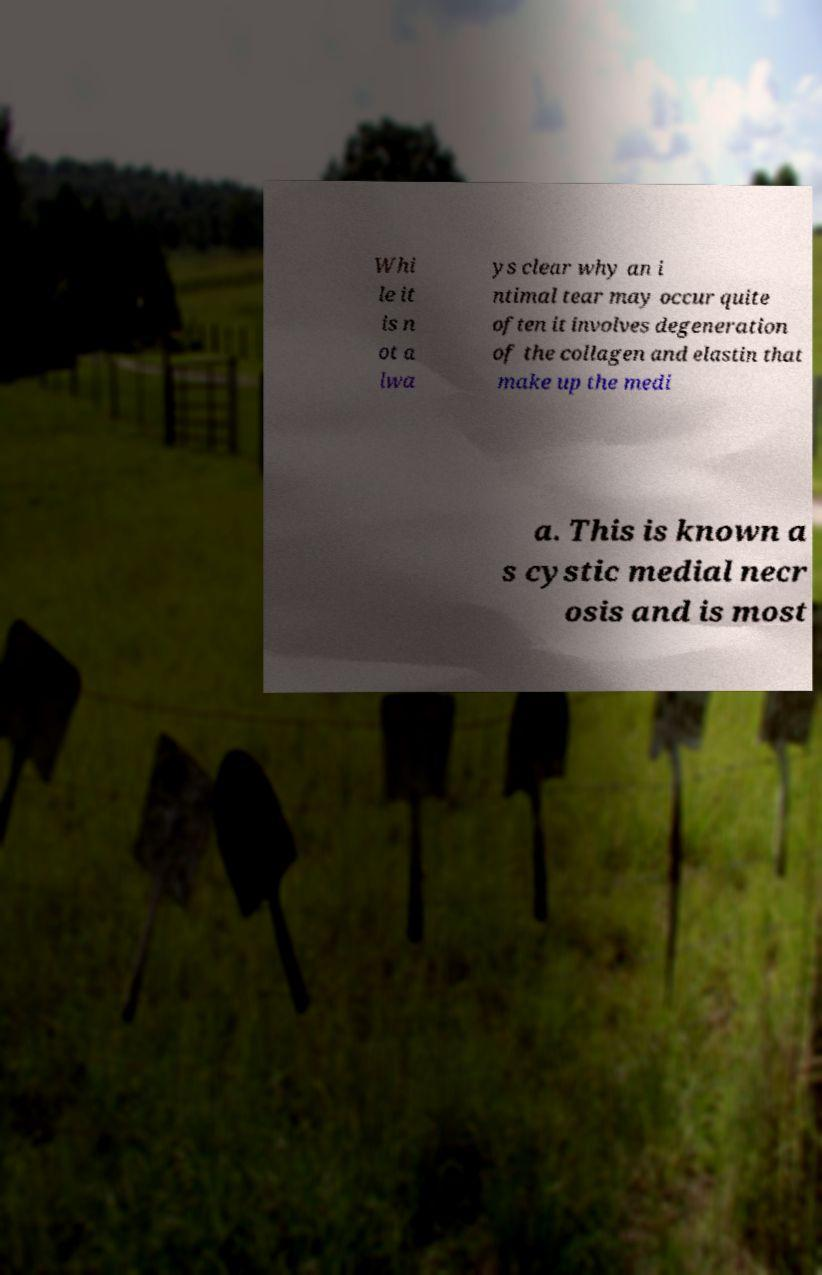What messages or text are displayed in this image? I need them in a readable, typed format. Whi le it is n ot a lwa ys clear why an i ntimal tear may occur quite often it involves degeneration of the collagen and elastin that make up the medi a. This is known a s cystic medial necr osis and is most 